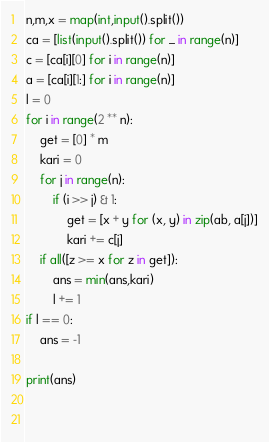Convert code to text. <code><loc_0><loc_0><loc_500><loc_500><_Python_>n,m,x = map(int,input().split())
ca = [list(input().split()) for _ in range(n)]
c = [ca[i][0] for i in range(n)]
a = [ca[i][1:] for i in range(n)]
l = 0
for i in range(2 ** n):
    get = [0] * m
    kari = 0
    for j in range(n):
        if (i >> j) & 1:
            get = [x + y for (x, y) in zip(ab, a[j])]
            kari += c[j]
    if all([z >= x for z in get]):
        ans = min(ans,kari)
        l += 1
if l == 0:
    ans = -1

print(ans)

            </code> 